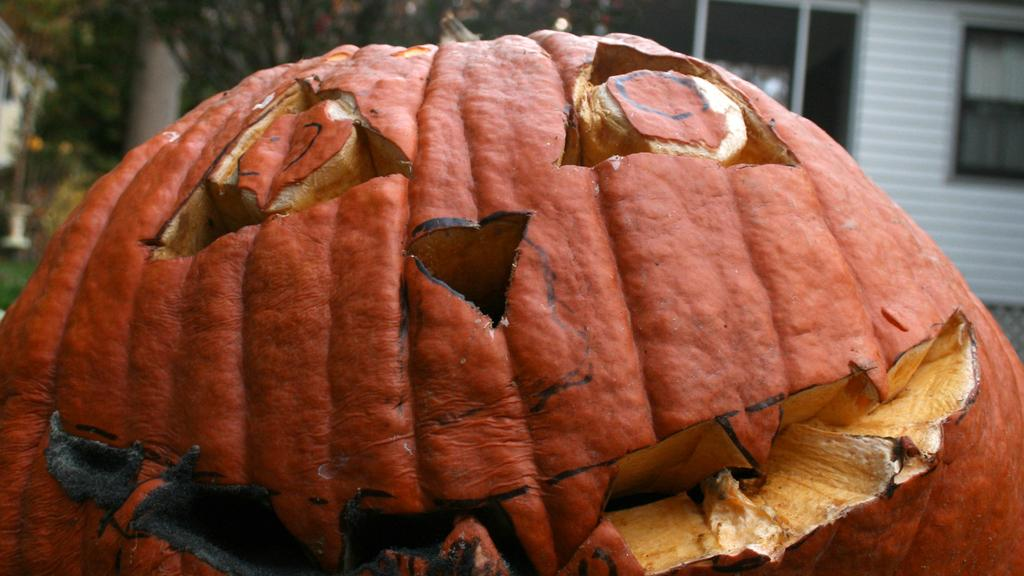What is the main object in the foreground of the image? There is a pumpkin in the foreground of the image. What can be seen in the background of the image? There is a building, windows, and trees visible in the background of the image. Can you describe the setting of the image? The image might have been taken on the road. What grade is the pumpkin in the image? The pumpkin is not a student, so it does not have a grade. Can you see any deer in the image? There are no deer present in the image; it features a pumpkin and a background with a building, windows, and trees. 